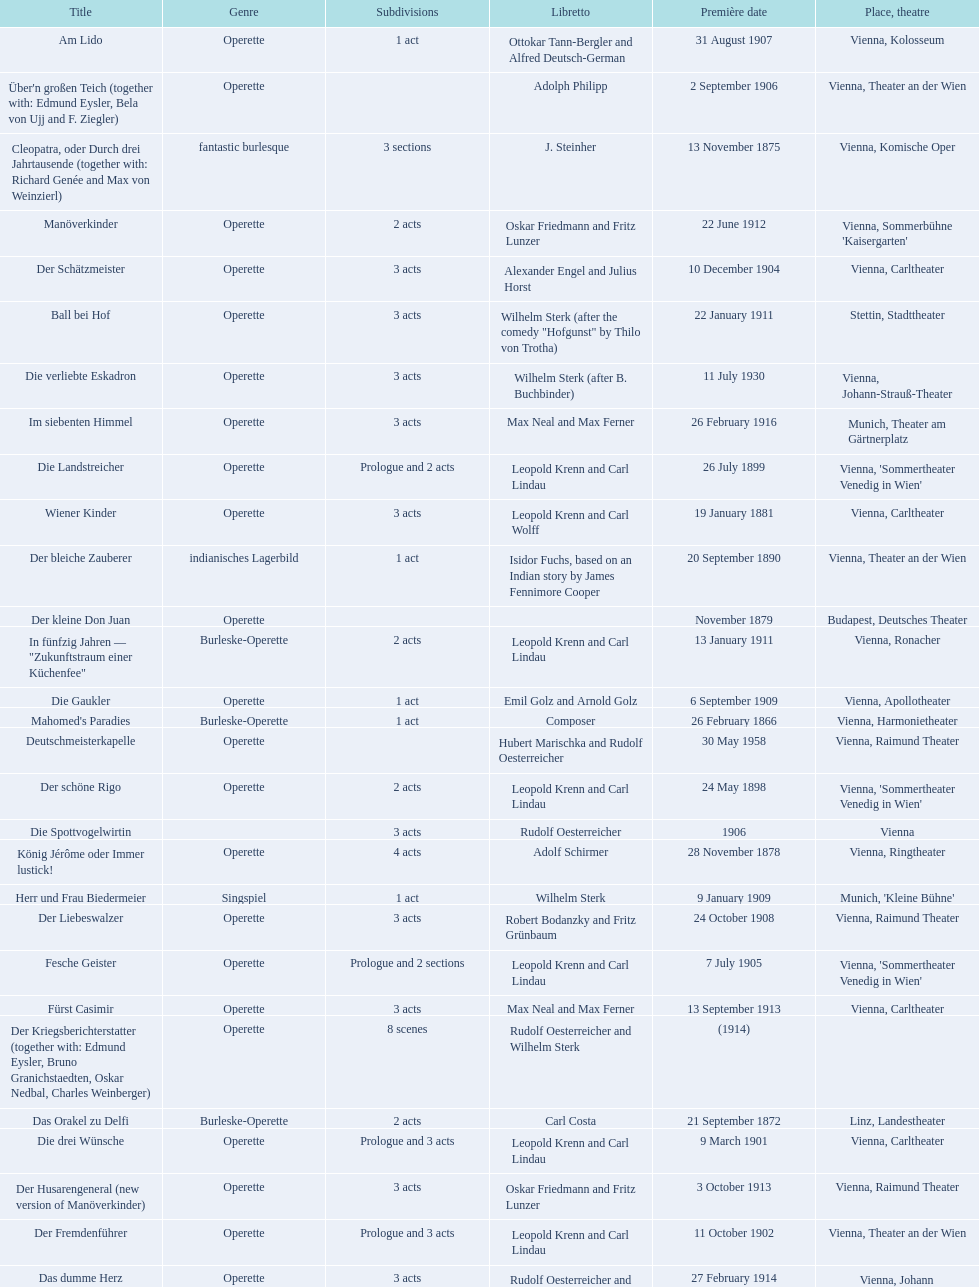How many number of 1 acts were there? 5. 